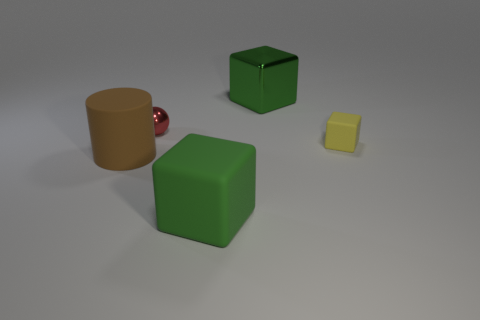Add 4 green shiny blocks. How many objects exist? 9 Subtract all yellow cubes. How many cubes are left? 2 Subtract all yellow rubber cubes. How many cubes are left? 2 Subtract all spheres. How many objects are left? 4 Subtract all purple cylinders. How many cyan spheres are left? 0 Subtract all big matte cylinders. Subtract all large cylinders. How many objects are left? 3 Add 2 tiny rubber things. How many tiny rubber things are left? 3 Add 1 large cyan matte cylinders. How many large cyan matte cylinders exist? 1 Subtract 0 yellow cylinders. How many objects are left? 5 Subtract all gray cylinders. Subtract all yellow balls. How many cylinders are left? 1 